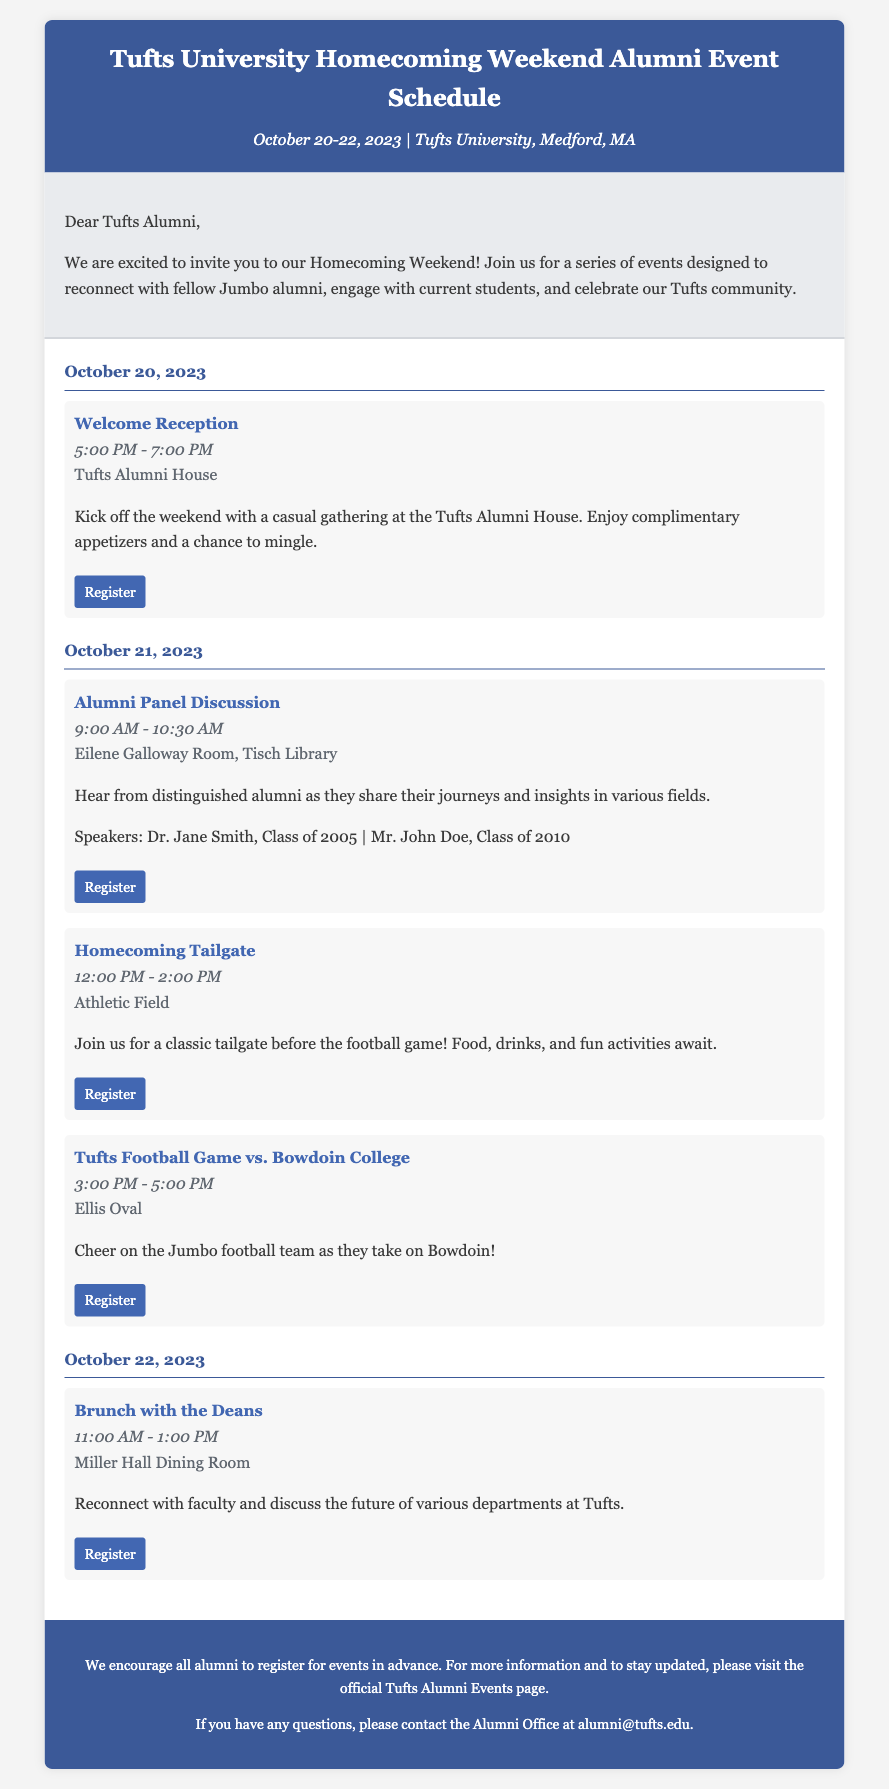What are the dates of Homecoming Weekend? The dates are mentioned in the header of the memo as October 20-22, 2023.
Answer: October 20-22, 2023 What is the title of the event on October 21? The title is found under the schedule for October 21, specifically highlighting the event that takes place that day.
Answer: Alumni Panel Discussion Where is the Welcome Reception held? The location is detailed in the event description for the Welcome Reception, specifying where it will take place.
Answer: Tufts Alumni House How many speakers are featured in the Alumni Panel Discussion? The document lists two speakers in the description of the Alumni Panel Discussion, requiring a count of the names mentioned.
Answer: Two What time does the Tufts Football Game start? The starting time is stated clearly in the schedule for the football game, noted in bold alongside the event title.
Answer: 3:00 PM What type of meal is served during the event with the Deans? The event description specifies the kind of meal associated with this particular gathering.
Answer: Brunch What is the recommended action for alumni regarding event registration? The footer contains guidance for alumni about participation and registration before events begin.
Answer: Register in advance Which department is mentioned in the Brunch with the Deans? The description of the event outlines its purpose and discusses engagement with faculty from a specific context.
Answer: Various departments 